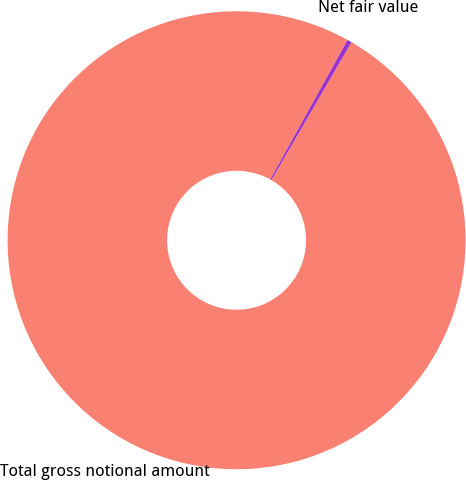<chart> <loc_0><loc_0><loc_500><loc_500><pie_chart><fcel>Total gross notional amount<fcel>Net fair value<nl><fcel>99.69%<fcel>0.31%<nl></chart> 